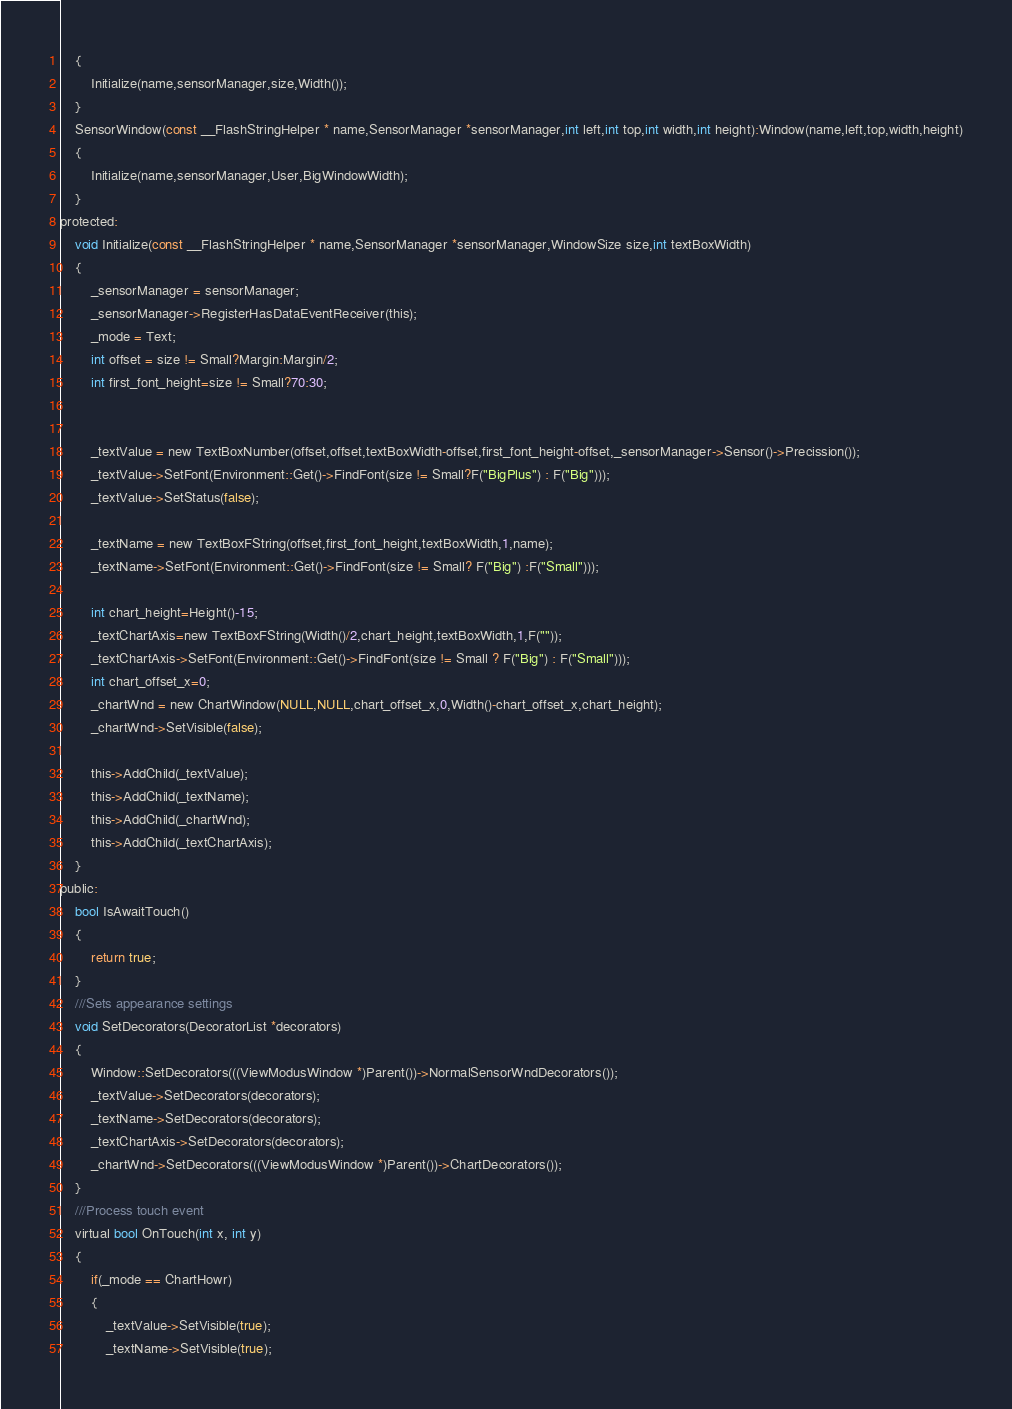Convert code to text. <code><loc_0><loc_0><loc_500><loc_500><_C_>	{
		Initialize(name,sensorManager,size,Width());
	}
	SensorWindow(const __FlashStringHelper * name,SensorManager *sensorManager,int left,int top,int width,int height):Window(name,left,top,width,height)
	{
		Initialize(name,sensorManager,User,BigWindowWidth);
	}
protected:
	void Initialize(const __FlashStringHelper * name,SensorManager *sensorManager,WindowSize size,int textBoxWidth)
	{
		_sensorManager = sensorManager;
		_sensorManager->RegisterHasDataEventReceiver(this);
		_mode = Text;
		int offset = size != Small?Margin:Margin/2;
		int first_font_height=size != Small?70:30;


		_textValue = new TextBoxNumber(offset,offset,textBoxWidth-offset,first_font_height-offset,_sensorManager->Sensor()->Precission());
		_textValue->SetFont(Environment::Get()->FindFont(size != Small?F("BigPlus") : F("Big")));
		_textValue->SetStatus(false);

		_textName = new TextBoxFString(offset,first_font_height,textBoxWidth,1,name);
		_textName->SetFont(Environment::Get()->FindFont(size != Small? F("Big") :F("Small")));

		int chart_height=Height()-15;
		_textChartAxis=new TextBoxFString(Width()/2,chart_height,textBoxWidth,1,F(""));
		_textChartAxis->SetFont(Environment::Get()->FindFont(size != Small ? F("Big") : F("Small")));
		int chart_offset_x=0;
		_chartWnd = new ChartWindow(NULL,NULL,chart_offset_x,0,Width()-chart_offset_x,chart_height);
		_chartWnd->SetVisible(false);

		this->AddChild(_textValue);
		this->AddChild(_textName);
		this->AddChild(_chartWnd);
		this->AddChild(_textChartAxis);
	}
public:
	bool IsAwaitTouch()
	{
		return true;
	}
	///Sets appearance settings
	void SetDecorators(DecoratorList *decorators)
	{
		Window::SetDecorators(((ViewModusWindow *)Parent())->NormalSensorWndDecorators());
		_textValue->SetDecorators(decorators);
		_textName->SetDecorators(decorators);
		_textChartAxis->SetDecorators(decorators);
		_chartWnd->SetDecorators(((ViewModusWindow *)Parent())->ChartDecorators());
	}
	///Process touch event
	virtual bool OnTouch(int x, int y)
	{
		if(_mode == ChartHowr)
		{
			_textValue->SetVisible(true);
			_textName->SetVisible(true);</code> 